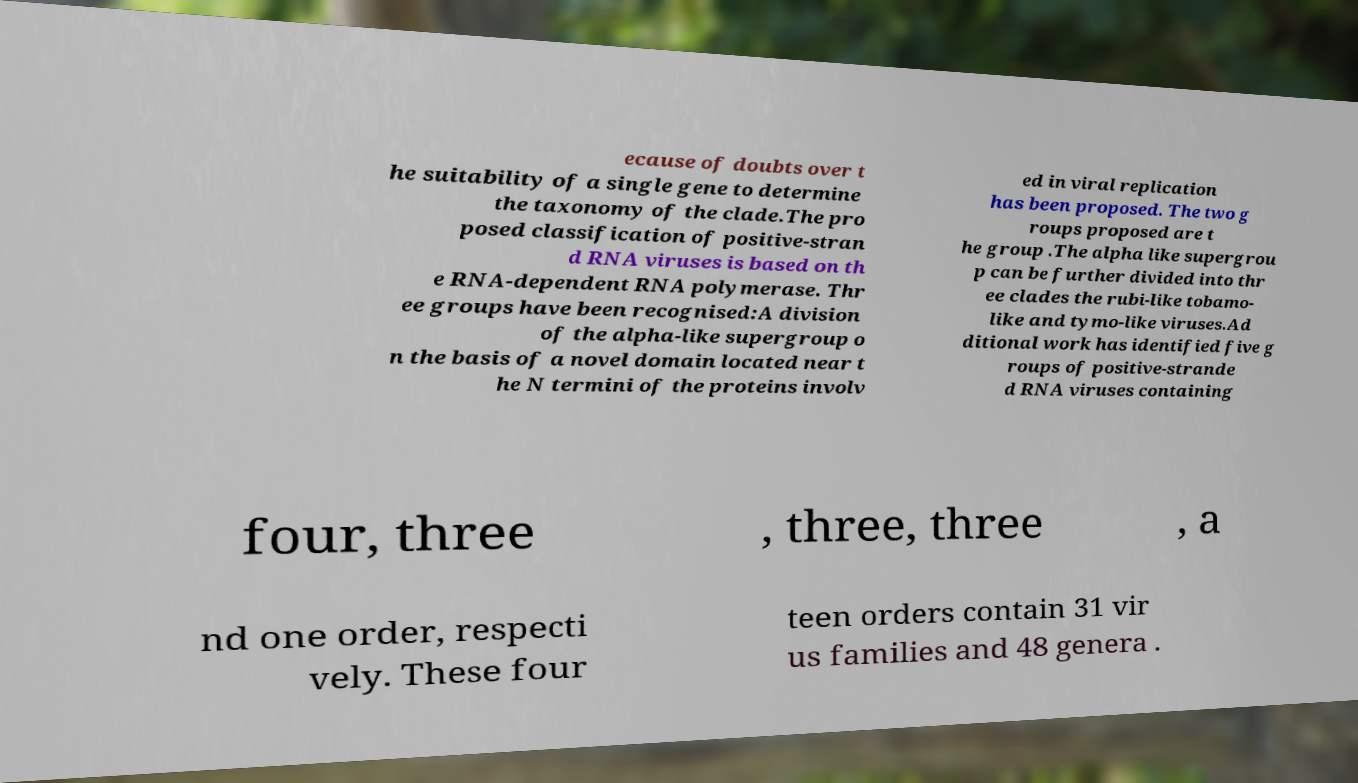What messages or text are displayed in this image? I need them in a readable, typed format. ecause of doubts over t he suitability of a single gene to determine the taxonomy of the clade.The pro posed classification of positive-stran d RNA viruses is based on th e RNA-dependent RNA polymerase. Thr ee groups have been recognised:A division of the alpha-like supergroup o n the basis of a novel domain located near t he N termini of the proteins involv ed in viral replication has been proposed. The two g roups proposed are t he group .The alpha like supergrou p can be further divided into thr ee clades the rubi-like tobamo- like and tymo-like viruses.Ad ditional work has identified five g roups of positive-strande d RNA viruses containing four, three , three, three , a nd one order, respecti vely. These four teen orders contain 31 vir us families and 48 genera . 